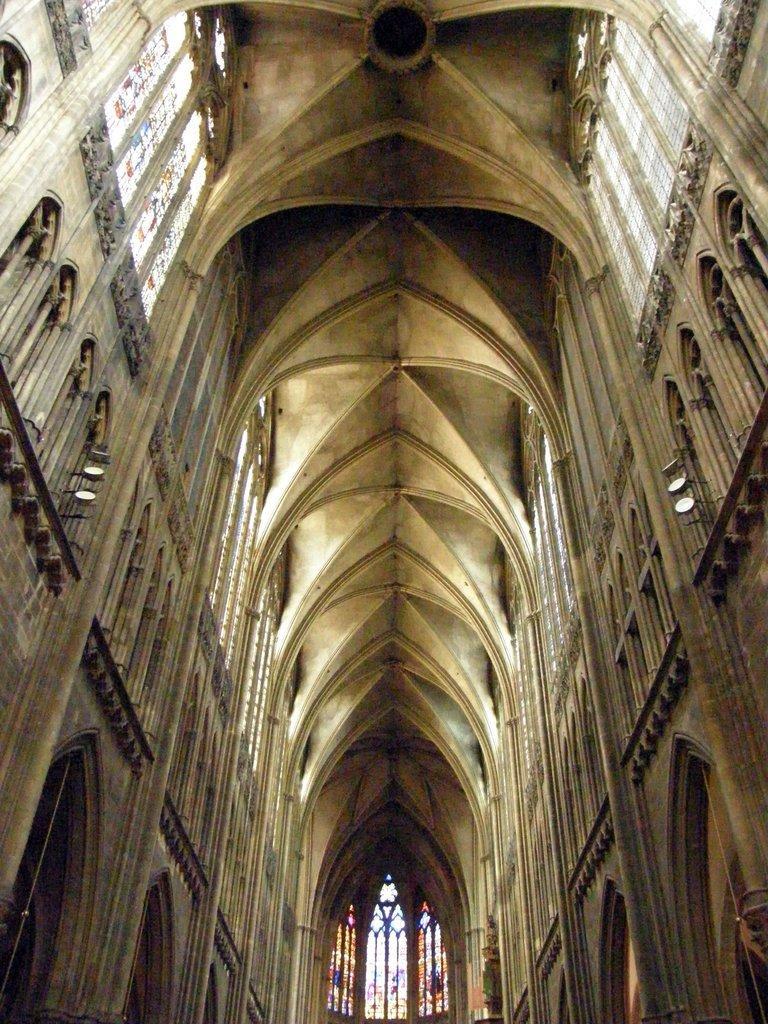Can you describe this image briefly? In this image we can see windows, doors, lights and wall. 